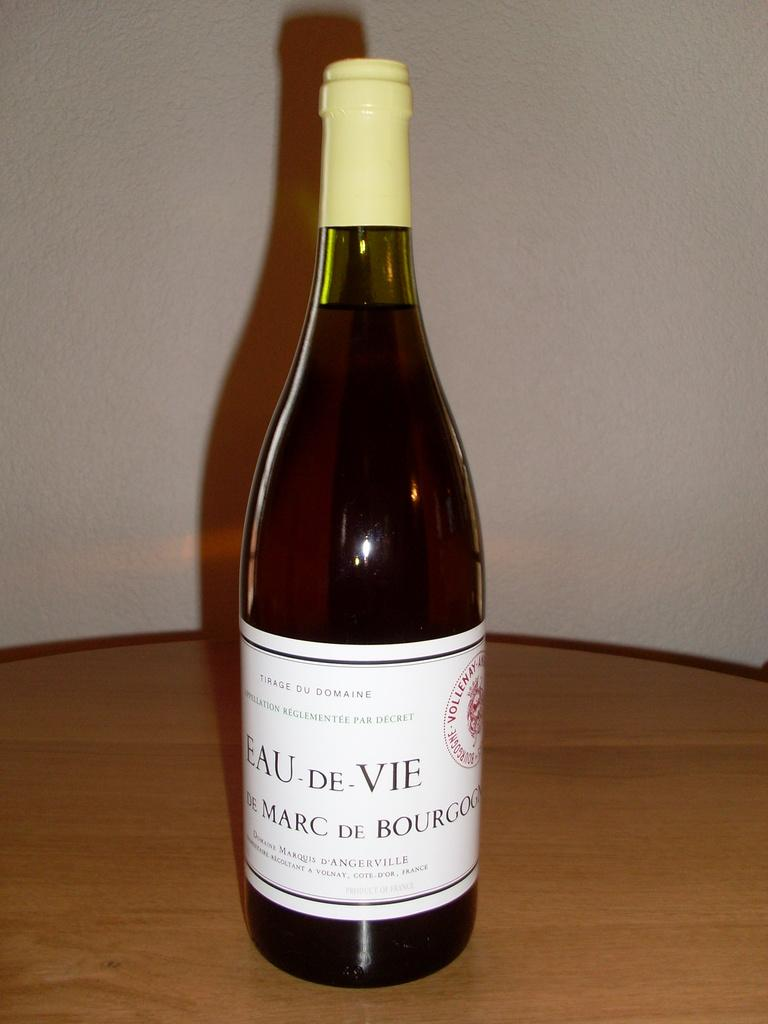What is on the bottle in the image? There is a sticker on the bottle in the image. Where is the bottle located? The bottle is placed on a wooden table. What can be seen in the background of the image? There is a wall in the background of the image. How many feet are visible on the shelf in the image? There is no shelf or feet present in the image; it only features a bottle with a sticker on a wooden table and a wall in the background. 